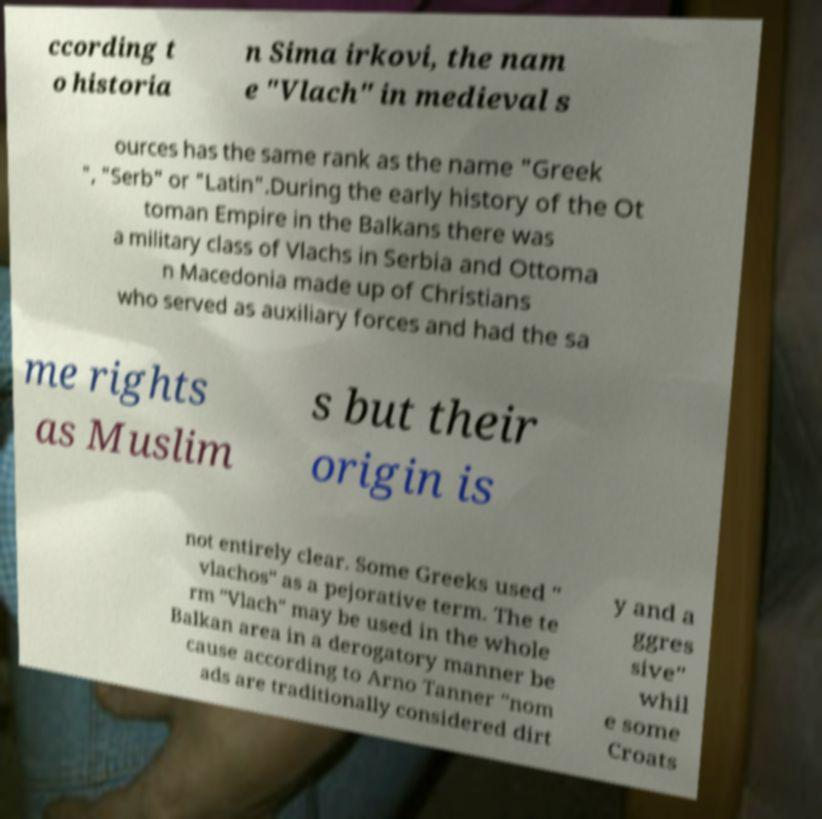Can you accurately transcribe the text from the provided image for me? ccording t o historia n Sima irkovi, the nam e "Vlach" in medieval s ources has the same rank as the name "Greek ", "Serb" or "Latin".During the early history of the Ot toman Empire in the Balkans there was a military class of Vlachs in Serbia and Ottoma n Macedonia made up of Christians who served as auxiliary forces and had the sa me rights as Muslim s but their origin is not entirely clear. Some Greeks used " vlachos" as a pejorative term. The te rm "Vlach" may be used in the whole Balkan area in a derogatory manner be cause according to Arno Tanner "nom ads are traditionally considered dirt y and a ggres sive" whil e some Croats 